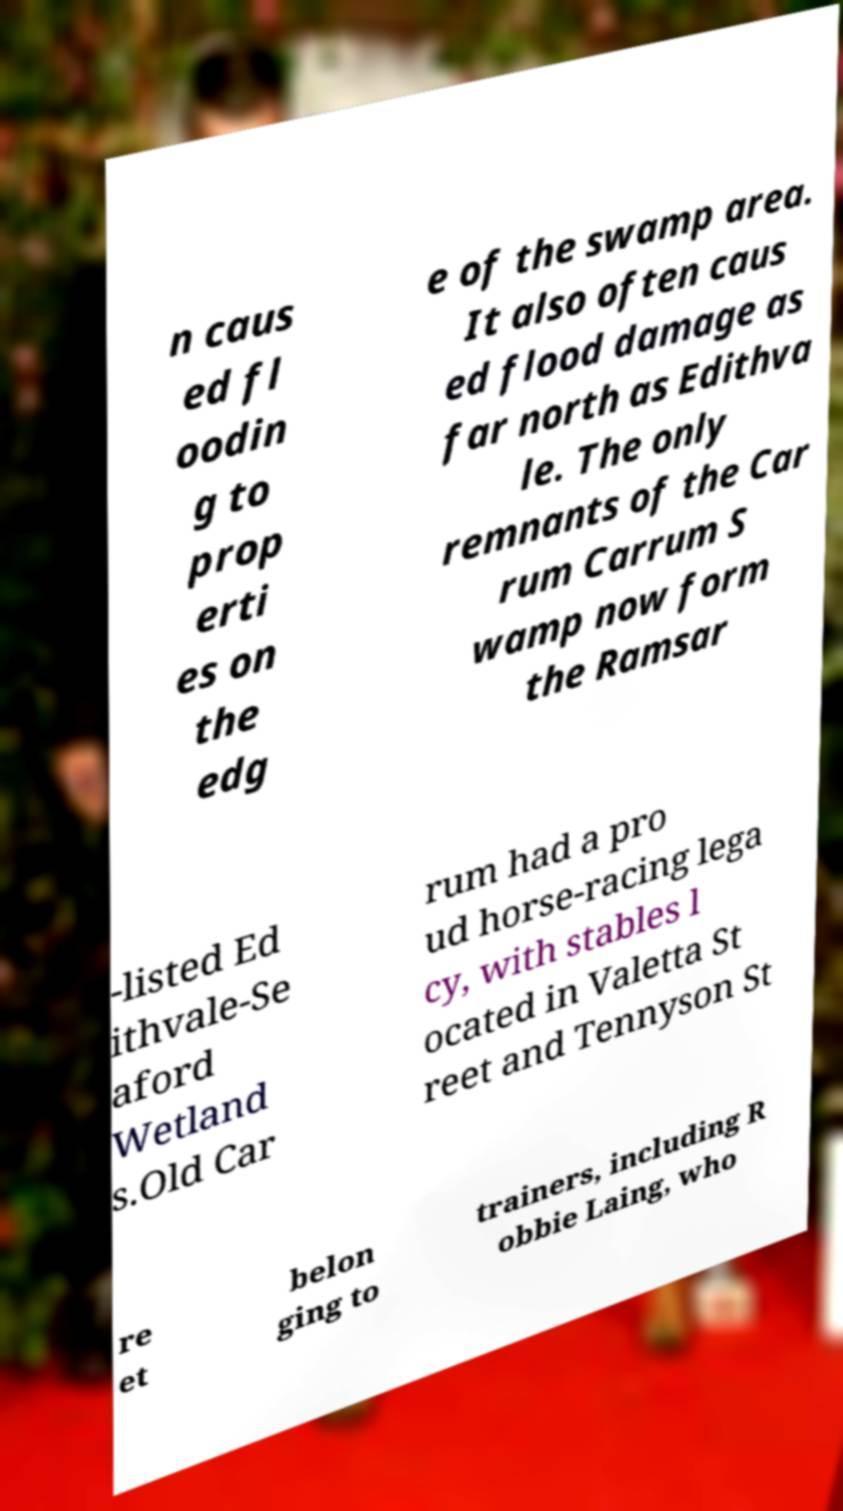Can you read and provide the text displayed in the image?This photo seems to have some interesting text. Can you extract and type it out for me? n caus ed fl oodin g to prop erti es on the edg e of the swamp area. It also often caus ed flood damage as far north as Edithva le. The only remnants of the Car rum Carrum S wamp now form the Ramsar -listed Ed ithvale-Se aford Wetland s.Old Car rum had a pro ud horse-racing lega cy, with stables l ocated in Valetta St reet and Tennyson St re et belon ging to trainers, including R obbie Laing, who 